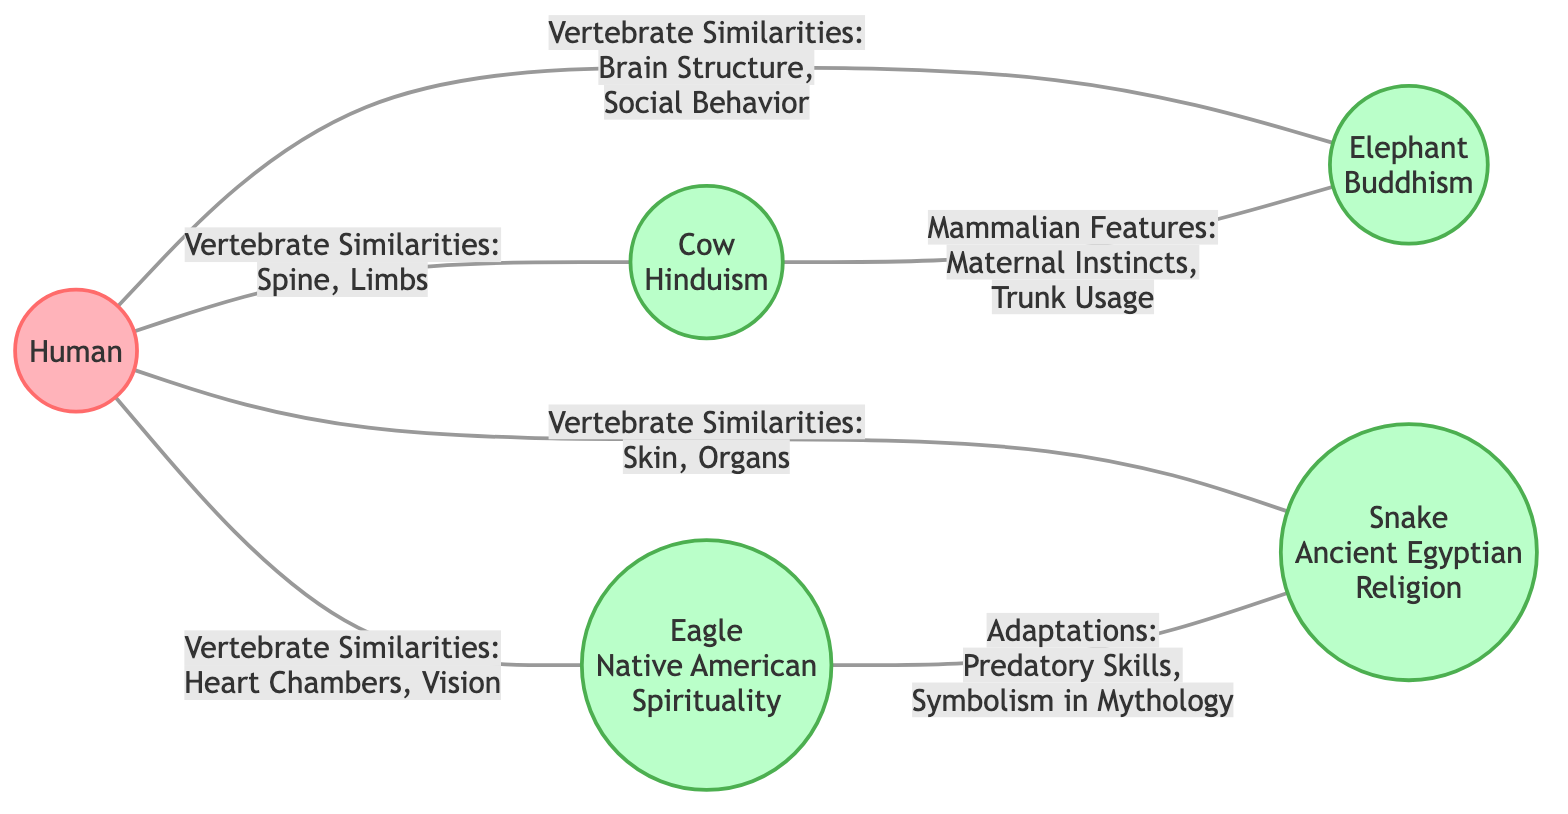What is the primary vertebrate similarity between humans and cows? The diagram indicates that the primary vertebrate similarity between humans and cows is the spine. Therefore, upon examining the connection between these two nodes, we see that the spine is explicitly listed in the relationship.
Answer: Spine How many animal species are represented in the diagram? By counting the nodes that represent animal species, we find four animals: Cow, Eagle, Snake, and Elephant. Thus, adding up these distinct nodes gives us the total number of animal species represented.
Answer: 4 What features do humans and elephants share according to the diagram? Looking at the connection between humans and elephants, the diagram states that they share similarities in brain structure and social behavior. Thus, identifying the features from this specific relationship leads directly to the answer.
Answer: Brain Structure, Social Behavior What adaptations are associated with eagles? The link to eagles in the diagram notes adaptations such as predatory skills and symbolism in mythology. By examining the relationship, we can deduce that these specific attributes relate to the eagle node.
Answer: Predatory Skills, Symbolism in Mythology Which animal shares mammalian features with cows related to trunk usage? The diagram illustrates a connection between cows and elephants, mentioning mammalian features such as trunk usage. This direct reference clarifies that the animal which shares these features with cows is the elephant.
Answer: Elephant What is the vertebrate similarity noted between humans and snakes? The diagram indicates that humans and snakes are similar in terms of skin and organs. Hence, examining this particular connection helps us identify the characteristics shared by both species.
Answer: Skin, Organs How many connections are there in the diagram from humans to other species? By reviewing the connections stemming from the human node, we find that there are four direct links to the cow, eagle, snake, and elephant. Counting these relationships gives us the total number of connections originating from humans.
Answer: 4 Which two species share a relationship involving predatory skills? The diagram highlights a relationship involving predatory skills between eagles and snakes. Analyzing their connection visually supports this conclusion regarding the species mentioned.
Answer: Eagle, Snake What type of features do humans and eagles share? According to the diagram, humans and eagles share vertebrate similarities such as heart chambers and vision. By observing the link between these two species, we identify the specific features they have in common.
Answer: Heart Chambers, Vision 